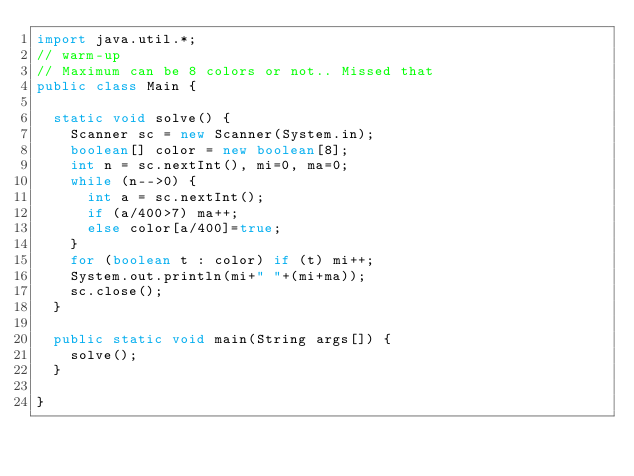<code> <loc_0><loc_0><loc_500><loc_500><_Java_>import java.util.*;
// warm-up
// Maximum can be 8 colors or not.. Missed that
public class Main {

	static void solve() {
		Scanner sc = new Scanner(System.in);
		boolean[] color = new boolean[8];
		int n = sc.nextInt(), mi=0, ma=0;
		while (n-->0) {
			int a = sc.nextInt();
			if (a/400>7) ma++;
			else color[a/400]=true;
		}
		for (boolean t : color) if (t) mi++;
		System.out.println(mi+" "+(mi+ma));
		sc.close();		
	}

	public static void main(String args[]) {
		solve();
	}

}</code> 